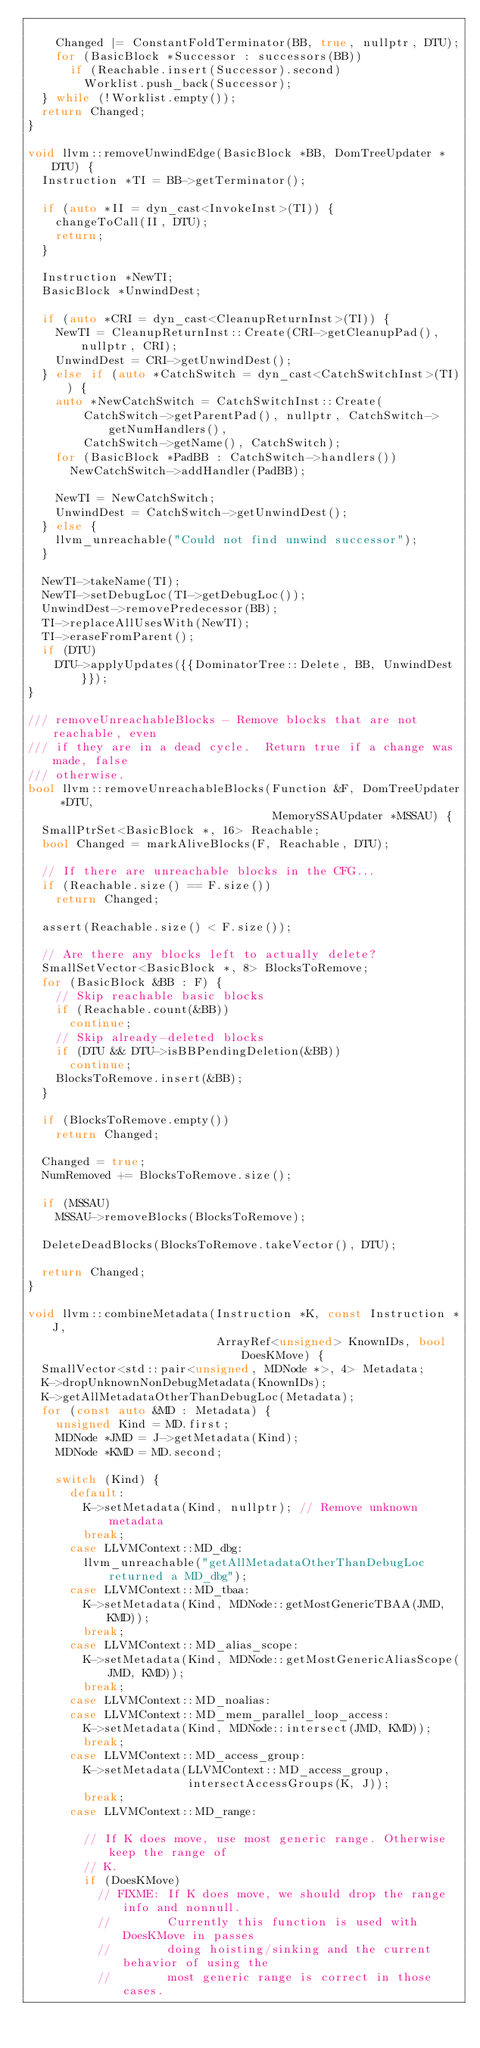<code> <loc_0><loc_0><loc_500><loc_500><_C++_>
    Changed |= ConstantFoldTerminator(BB, true, nullptr, DTU);
    for (BasicBlock *Successor : successors(BB))
      if (Reachable.insert(Successor).second)
        Worklist.push_back(Successor);
  } while (!Worklist.empty());
  return Changed;
}

void llvm::removeUnwindEdge(BasicBlock *BB, DomTreeUpdater *DTU) {
  Instruction *TI = BB->getTerminator();

  if (auto *II = dyn_cast<InvokeInst>(TI)) {
    changeToCall(II, DTU);
    return;
  }

  Instruction *NewTI;
  BasicBlock *UnwindDest;

  if (auto *CRI = dyn_cast<CleanupReturnInst>(TI)) {
    NewTI = CleanupReturnInst::Create(CRI->getCleanupPad(), nullptr, CRI);
    UnwindDest = CRI->getUnwindDest();
  } else if (auto *CatchSwitch = dyn_cast<CatchSwitchInst>(TI)) {
    auto *NewCatchSwitch = CatchSwitchInst::Create(
        CatchSwitch->getParentPad(), nullptr, CatchSwitch->getNumHandlers(),
        CatchSwitch->getName(), CatchSwitch);
    for (BasicBlock *PadBB : CatchSwitch->handlers())
      NewCatchSwitch->addHandler(PadBB);

    NewTI = NewCatchSwitch;
    UnwindDest = CatchSwitch->getUnwindDest();
  } else {
    llvm_unreachable("Could not find unwind successor");
  }

  NewTI->takeName(TI);
  NewTI->setDebugLoc(TI->getDebugLoc());
  UnwindDest->removePredecessor(BB);
  TI->replaceAllUsesWith(NewTI);
  TI->eraseFromParent();
  if (DTU)
    DTU->applyUpdates({{DominatorTree::Delete, BB, UnwindDest}});
}

/// removeUnreachableBlocks - Remove blocks that are not reachable, even
/// if they are in a dead cycle.  Return true if a change was made, false
/// otherwise.
bool llvm::removeUnreachableBlocks(Function &F, DomTreeUpdater *DTU,
                                   MemorySSAUpdater *MSSAU) {
  SmallPtrSet<BasicBlock *, 16> Reachable;
  bool Changed = markAliveBlocks(F, Reachable, DTU);

  // If there are unreachable blocks in the CFG...
  if (Reachable.size() == F.size())
    return Changed;

  assert(Reachable.size() < F.size());

  // Are there any blocks left to actually delete?
  SmallSetVector<BasicBlock *, 8> BlocksToRemove;
  for (BasicBlock &BB : F) {
    // Skip reachable basic blocks
    if (Reachable.count(&BB))
      continue;
    // Skip already-deleted blocks
    if (DTU && DTU->isBBPendingDeletion(&BB))
      continue;
    BlocksToRemove.insert(&BB);
  }

  if (BlocksToRemove.empty())
    return Changed;

  Changed = true;
  NumRemoved += BlocksToRemove.size();

  if (MSSAU)
    MSSAU->removeBlocks(BlocksToRemove);

  DeleteDeadBlocks(BlocksToRemove.takeVector(), DTU);

  return Changed;
}

void llvm::combineMetadata(Instruction *K, const Instruction *J,
                           ArrayRef<unsigned> KnownIDs, bool DoesKMove) {
  SmallVector<std::pair<unsigned, MDNode *>, 4> Metadata;
  K->dropUnknownNonDebugMetadata(KnownIDs);
  K->getAllMetadataOtherThanDebugLoc(Metadata);
  for (const auto &MD : Metadata) {
    unsigned Kind = MD.first;
    MDNode *JMD = J->getMetadata(Kind);
    MDNode *KMD = MD.second;

    switch (Kind) {
      default:
        K->setMetadata(Kind, nullptr); // Remove unknown metadata
        break;
      case LLVMContext::MD_dbg:
        llvm_unreachable("getAllMetadataOtherThanDebugLoc returned a MD_dbg");
      case LLVMContext::MD_tbaa:
        K->setMetadata(Kind, MDNode::getMostGenericTBAA(JMD, KMD));
        break;
      case LLVMContext::MD_alias_scope:
        K->setMetadata(Kind, MDNode::getMostGenericAliasScope(JMD, KMD));
        break;
      case LLVMContext::MD_noalias:
      case LLVMContext::MD_mem_parallel_loop_access:
        K->setMetadata(Kind, MDNode::intersect(JMD, KMD));
        break;
      case LLVMContext::MD_access_group:
        K->setMetadata(LLVMContext::MD_access_group,
                       intersectAccessGroups(K, J));
        break;
      case LLVMContext::MD_range:

        // If K does move, use most generic range. Otherwise keep the range of
        // K.
        if (DoesKMove)
          // FIXME: If K does move, we should drop the range info and nonnull.
          //        Currently this function is used with DoesKMove in passes
          //        doing hoisting/sinking and the current behavior of using the
          //        most generic range is correct in those cases.</code> 